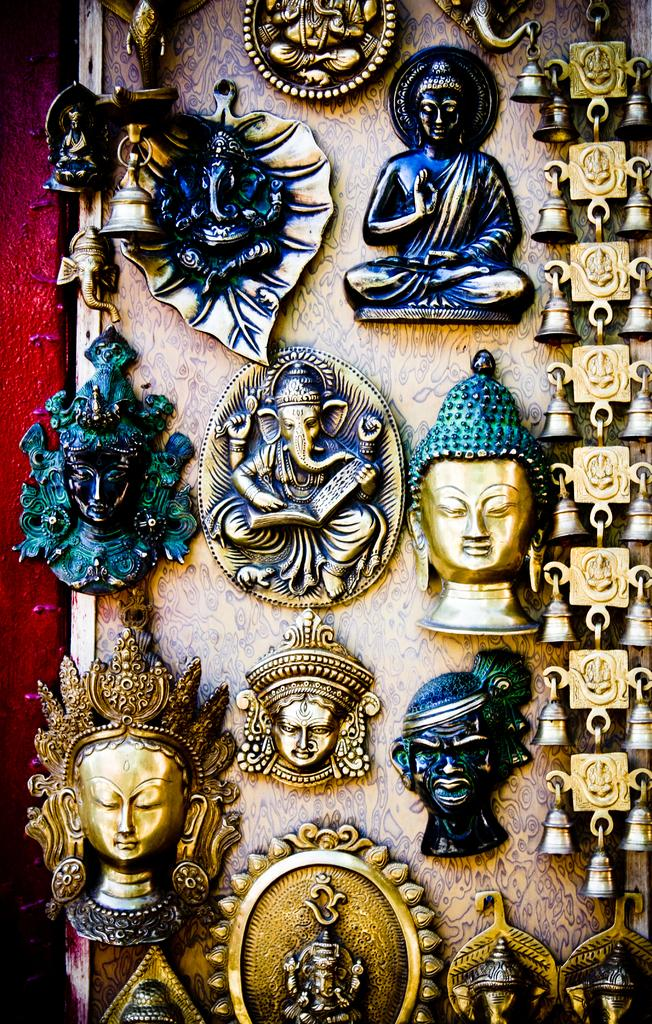What can be seen in the image? There are idols in the image. Where are the idols located? The idols are attached to a wall. What type of fang can be seen hanging from the idols in the image? There are no fangs present in the image; it features idols attached to a wall. What is the idols using to drink milk in the image? There is no milk or drinking activity depicted in the image. 